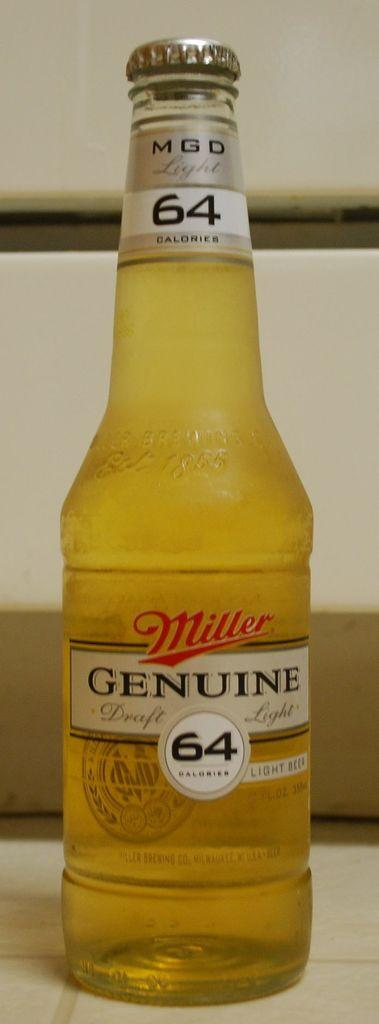Provide a one-sentence caption for the provided image. a bottle of Miller Genuine 64 calories light beer. 